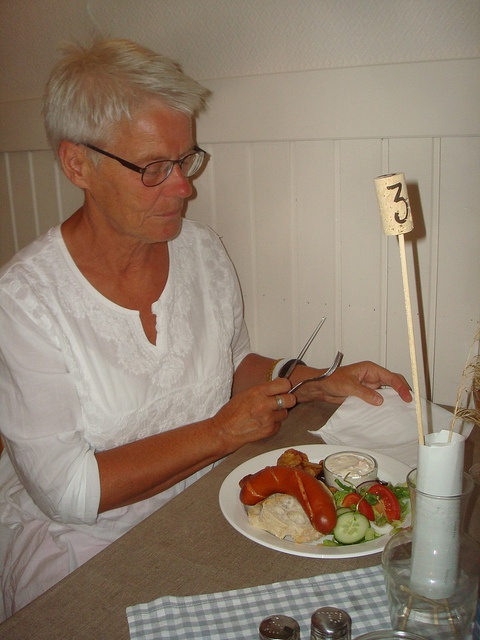Describe the objects in this image and their specific colors. I can see people in maroon, darkgray, brown, and gray tones, dining table in maroon, darkgray, gray, and tan tones, vase in maroon, gray, darkgray, and black tones, hot dog in maroon, brown, and tan tones, and cup in maroon, tan, and gray tones in this image. 